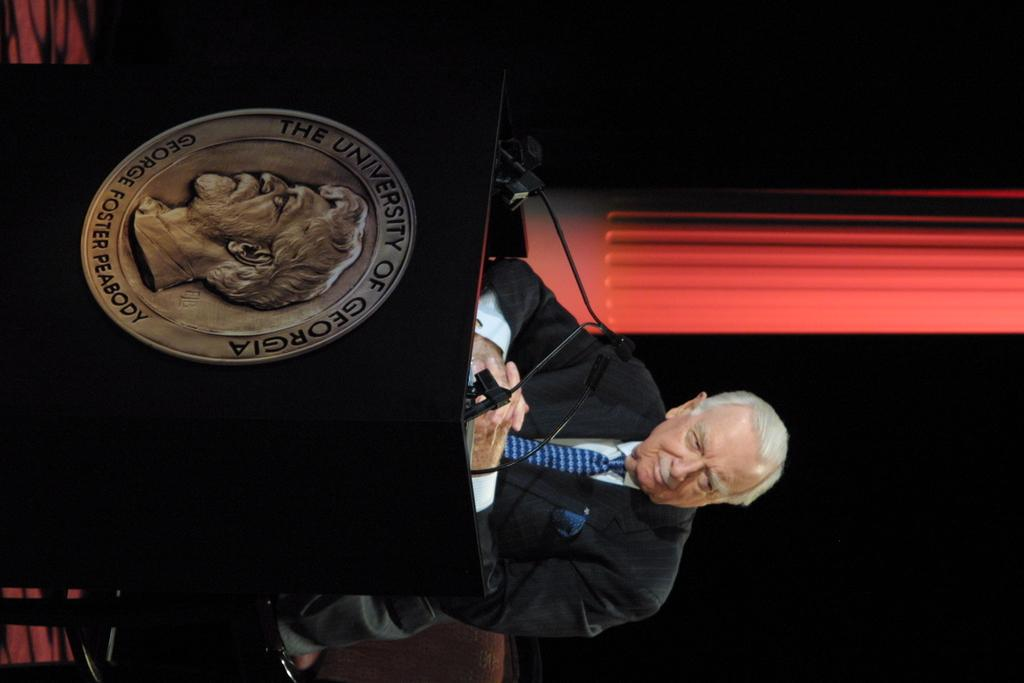<image>
Provide a brief description of the given image. A man is standing at a University of Georgia podium. 